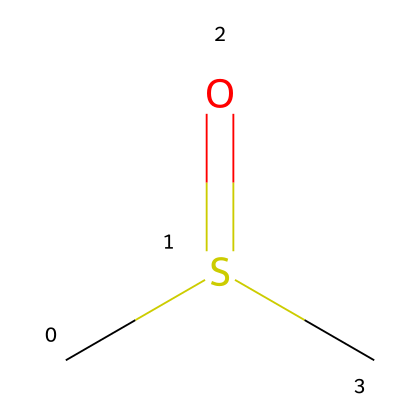What is the molecular formula of dimethyl sulfoxide? The molecular structure can be analyzed to determine the elements present and their quantities. The SMILES notation reveals two carbon (C) atoms, one sulfur (S) atom, and one oxygen (O) atom, leading to the formula C2H6OS.
Answer: C2H6OS How many carbon atoms are in dimethyl sulfoxide? By examining the SMILES representation, there are two 'C' characters, indicating that there are two carbon atoms in the structure.
Answer: 2 Is dimethyl sulfoxide an organosulfur compound? The presence of sulfur in the chemical structure, specifically noted in the SMILES notation (the 'S'), indicates that it belongs to the organosulfur family.
Answer: yes What type of bond connects the sulfur to the oxygen in dimethyl sulfoxide? The notation 'S(=O)' indicates a double bond between the sulfur and the oxygen, denoting a carbonyl-type functional group characteristic of sulfoxides.
Answer: double bond What is the oxidation state of the sulfur atom in dimethyl sulfoxide? Considering the structure, the sulfur atom is bonded to oxygen (which is more electronegative) and has a typical oxidation state of +6 in sulfoxides. Therefore, the oxidation state of sulfur is calculated as +6.
Answer: +6 What functional group is represented in the structure of dimethyl sulfoxide? The presence of the sulfur atom bonded to an oxygen atom (S=O) indicates that dimethyl sulfoxide contains a sulfoxide functional group, characteristic of this class of compounds.
Answer: sulfoxide 